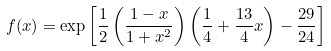<formula> <loc_0><loc_0><loc_500><loc_500>f ( x ) = \exp \left [ \frac { 1 } { 2 } \left ( \frac { 1 - x } { 1 + x ^ { 2 } } \right ) \left ( \frac { 1 } { 4 } + \frac { 1 3 } { 4 } x \right ) - \frac { 2 9 } { 2 4 } \right ]</formula> 